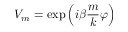<formula> <loc_0><loc_0><loc_500><loc_500>V _ { m } = \exp \left ( { i \beta } \frac { m } { k } \varphi \right )</formula> 